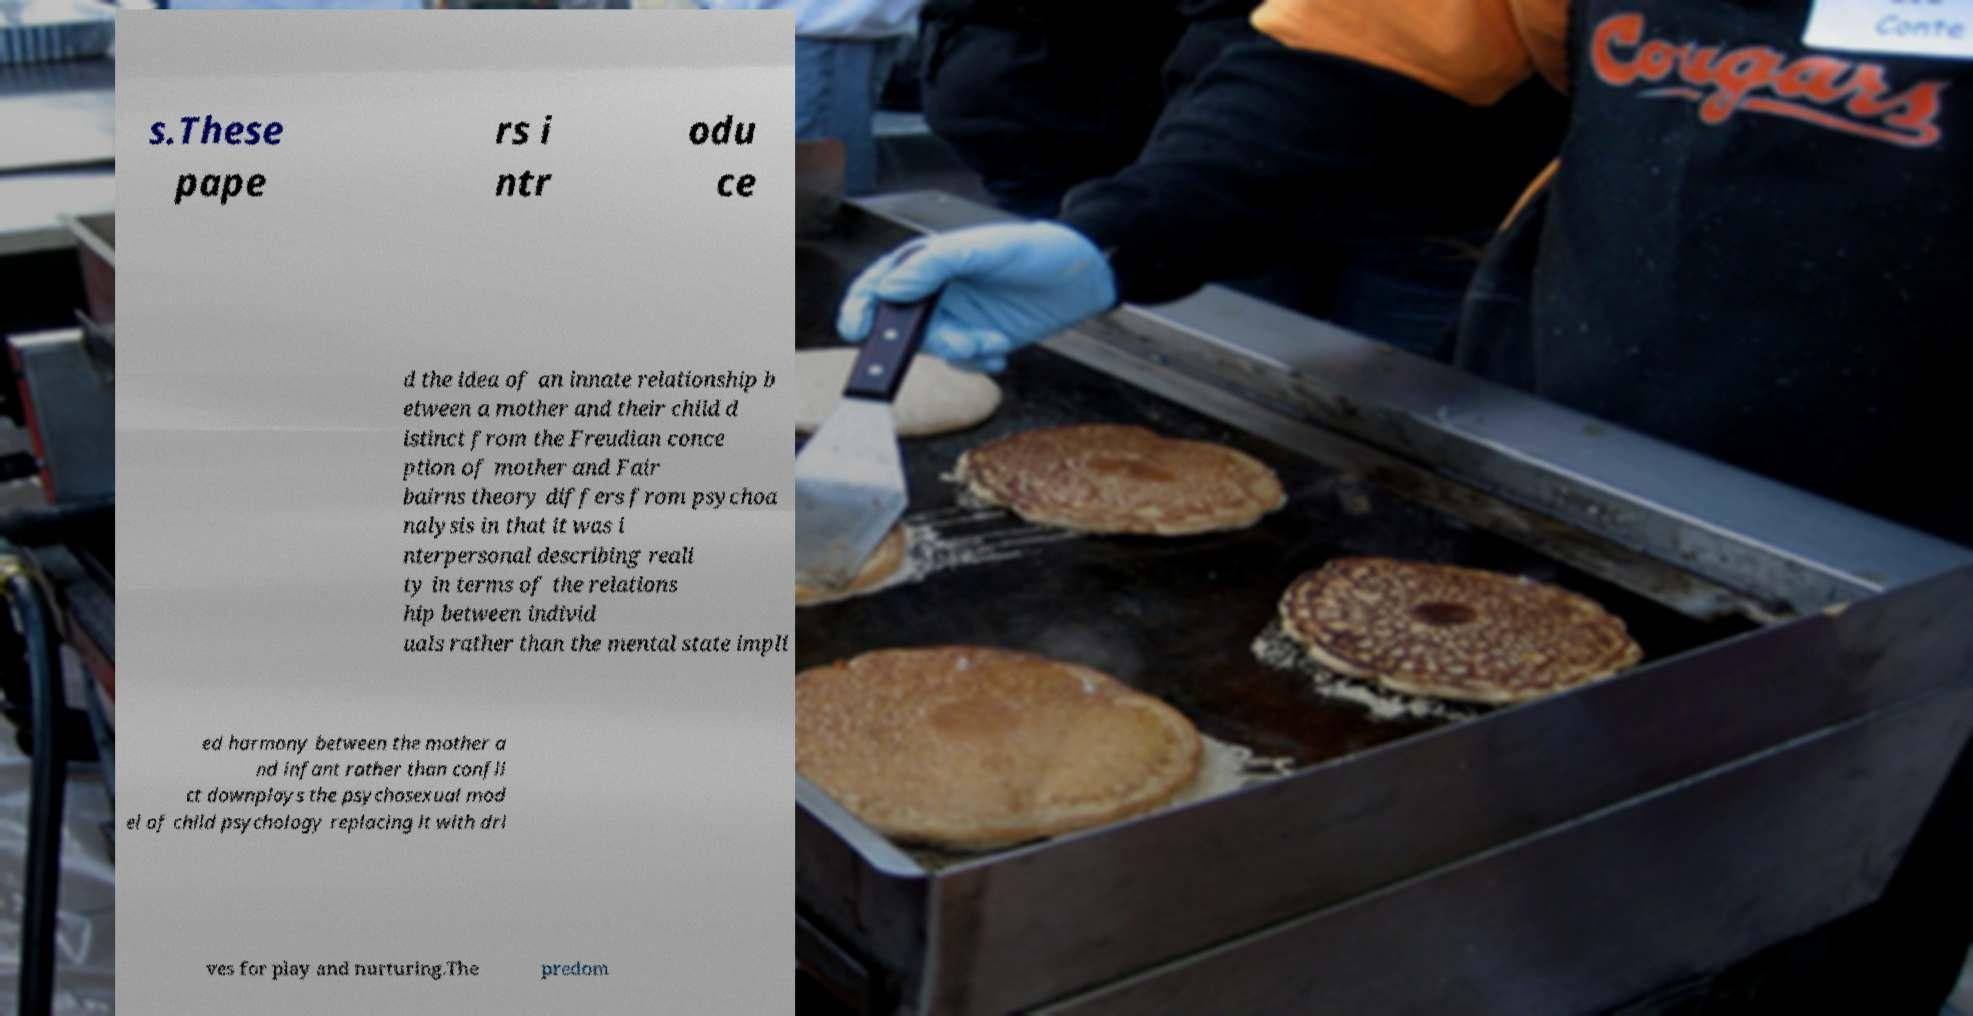Could you assist in decoding the text presented in this image and type it out clearly? s.These pape rs i ntr odu ce d the idea of an innate relationship b etween a mother and their child d istinct from the Freudian conce ption of mother and Fair bairns theory differs from psychoa nalysis in that it was i nterpersonal describing reali ty in terms of the relations hip between individ uals rather than the mental state impli ed harmony between the mother a nd infant rather than confli ct downplays the psychosexual mod el of child psychology replacing it with dri ves for play and nurturing.The predom 